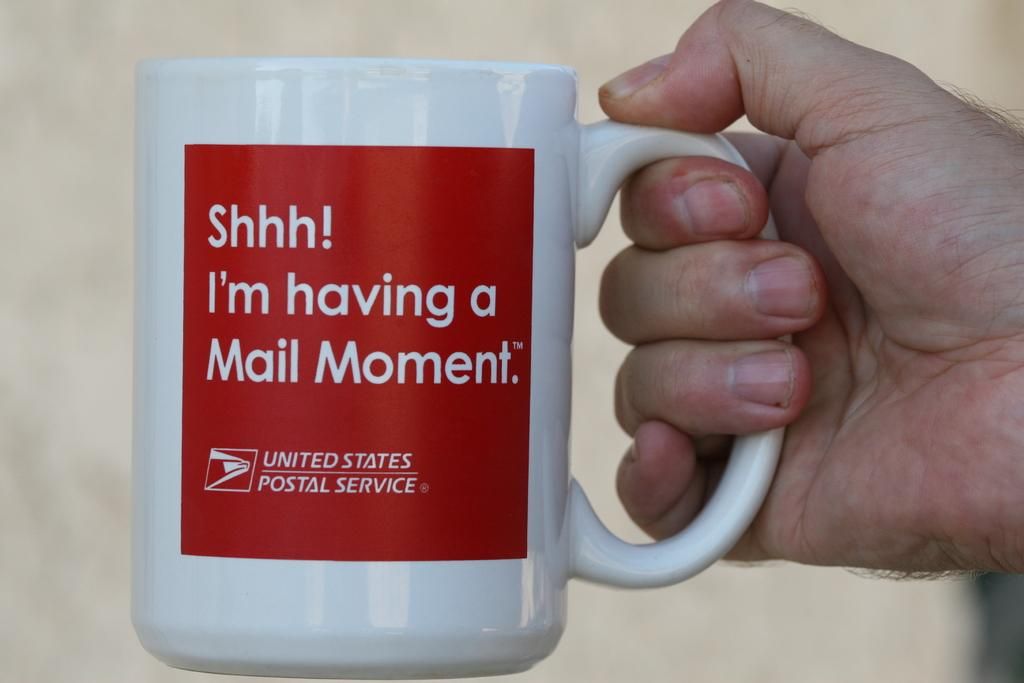<image>
Provide a brief description of the given image. a united states postal service cup with a cute saying 